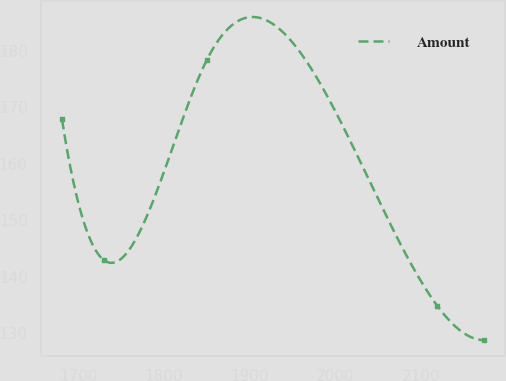Convert chart. <chart><loc_0><loc_0><loc_500><loc_500><line_chart><ecel><fcel>Amount<nl><fcel>1681.09<fcel>167.81<nl><fcel>1730.31<fcel>142.89<nl><fcel>1849.84<fcel>178.31<nl><fcel>2118.81<fcel>134.8<nl><fcel>2173.32<fcel>128.77<nl></chart> 